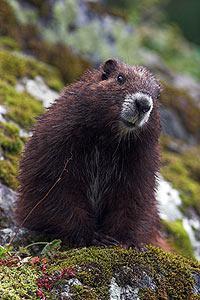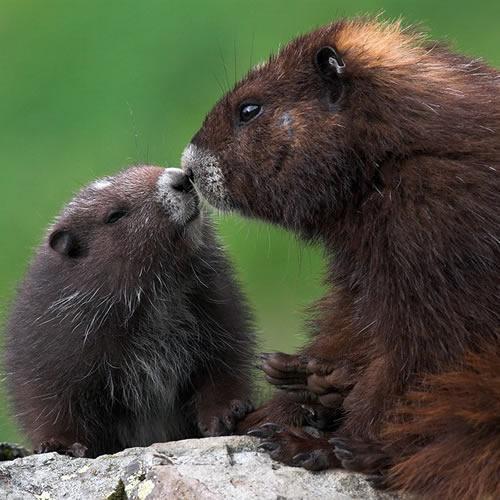The first image is the image on the left, the second image is the image on the right. For the images shown, is this caption "the animal is standing up on the left pic" true? Answer yes or no. No. The first image is the image on the left, the second image is the image on the right. For the images shown, is this caption "One of the gophers has a long white underbelly and the gopher that is sitting on a rock or mossy log, does not." true? Answer yes or no. No. 